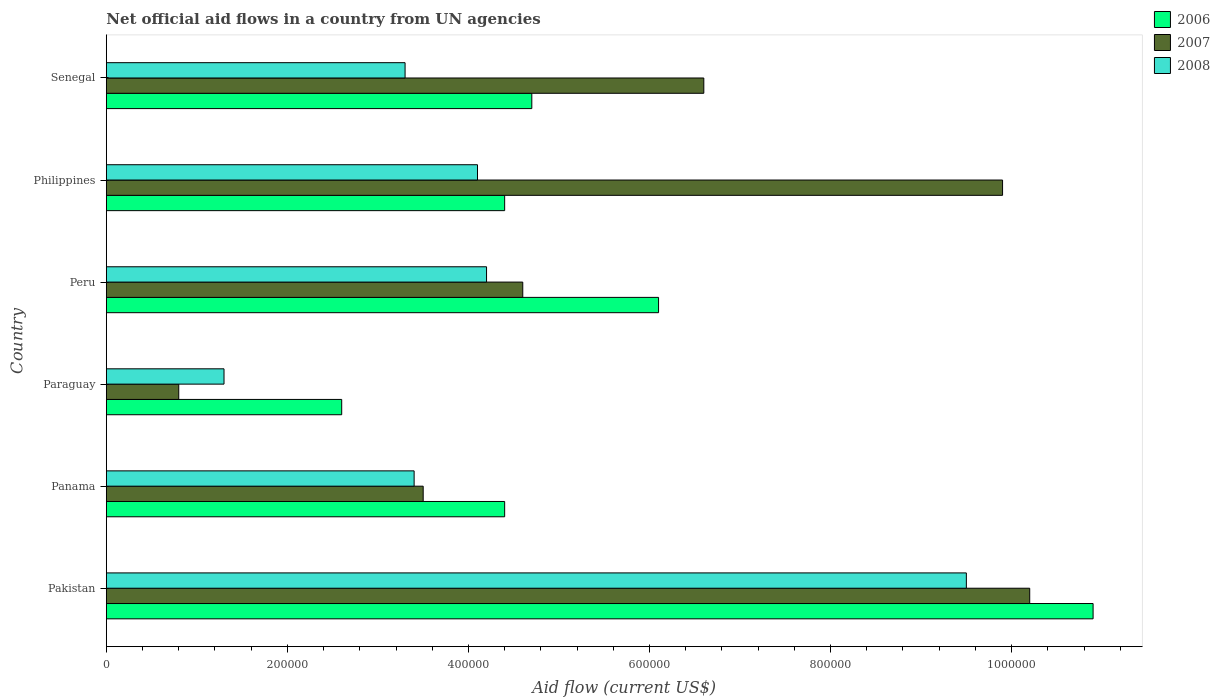How many different coloured bars are there?
Provide a short and direct response. 3. How many groups of bars are there?
Make the answer very short. 6. How many bars are there on the 3rd tick from the top?
Provide a short and direct response. 3. What is the net official aid flow in 2008 in Paraguay?
Ensure brevity in your answer.  1.30e+05. Across all countries, what is the maximum net official aid flow in 2008?
Offer a terse response. 9.50e+05. Across all countries, what is the minimum net official aid flow in 2006?
Make the answer very short. 2.60e+05. In which country was the net official aid flow in 2006 minimum?
Keep it short and to the point. Paraguay. What is the total net official aid flow in 2006 in the graph?
Keep it short and to the point. 3.31e+06. What is the average net official aid flow in 2006 per country?
Provide a short and direct response. 5.52e+05. What is the difference between the net official aid flow in 2006 and net official aid flow in 2008 in Paraguay?
Provide a short and direct response. 1.30e+05. What is the ratio of the net official aid flow in 2006 in Peru to that in Senegal?
Ensure brevity in your answer.  1.3. Is the net official aid flow in 2008 in Panama less than that in Paraguay?
Provide a short and direct response. No. What is the difference between the highest and the second highest net official aid flow in 2008?
Ensure brevity in your answer.  5.30e+05. What is the difference between the highest and the lowest net official aid flow in 2006?
Your response must be concise. 8.30e+05. In how many countries, is the net official aid flow in 2007 greater than the average net official aid flow in 2007 taken over all countries?
Keep it short and to the point. 3. What does the 1st bar from the top in Philippines represents?
Ensure brevity in your answer.  2008. What does the 1st bar from the bottom in Peru represents?
Give a very brief answer. 2006. Are all the bars in the graph horizontal?
Keep it short and to the point. Yes. How many countries are there in the graph?
Offer a very short reply. 6. What is the difference between two consecutive major ticks on the X-axis?
Provide a succinct answer. 2.00e+05. Does the graph contain any zero values?
Give a very brief answer. No. Does the graph contain grids?
Your answer should be very brief. No. How many legend labels are there?
Your answer should be compact. 3. What is the title of the graph?
Make the answer very short. Net official aid flows in a country from UN agencies. Does "1997" appear as one of the legend labels in the graph?
Provide a succinct answer. No. What is the label or title of the X-axis?
Your answer should be very brief. Aid flow (current US$). What is the Aid flow (current US$) of 2006 in Pakistan?
Offer a terse response. 1.09e+06. What is the Aid flow (current US$) in 2007 in Pakistan?
Provide a succinct answer. 1.02e+06. What is the Aid flow (current US$) of 2008 in Pakistan?
Your response must be concise. 9.50e+05. What is the Aid flow (current US$) in 2006 in Paraguay?
Provide a succinct answer. 2.60e+05. What is the Aid flow (current US$) in 2007 in Paraguay?
Your response must be concise. 8.00e+04. What is the Aid flow (current US$) in 2007 in Peru?
Ensure brevity in your answer.  4.60e+05. What is the Aid flow (current US$) of 2008 in Peru?
Provide a short and direct response. 4.20e+05. What is the Aid flow (current US$) of 2006 in Philippines?
Your response must be concise. 4.40e+05. What is the Aid flow (current US$) of 2007 in Philippines?
Offer a terse response. 9.90e+05. What is the Aid flow (current US$) of 2008 in Philippines?
Your response must be concise. 4.10e+05. What is the Aid flow (current US$) in 2007 in Senegal?
Give a very brief answer. 6.60e+05. Across all countries, what is the maximum Aid flow (current US$) in 2006?
Offer a terse response. 1.09e+06. Across all countries, what is the maximum Aid flow (current US$) of 2007?
Your response must be concise. 1.02e+06. Across all countries, what is the maximum Aid flow (current US$) of 2008?
Your answer should be compact. 9.50e+05. Across all countries, what is the minimum Aid flow (current US$) in 2006?
Your response must be concise. 2.60e+05. What is the total Aid flow (current US$) of 2006 in the graph?
Your response must be concise. 3.31e+06. What is the total Aid flow (current US$) in 2007 in the graph?
Make the answer very short. 3.56e+06. What is the total Aid flow (current US$) of 2008 in the graph?
Provide a succinct answer. 2.58e+06. What is the difference between the Aid flow (current US$) in 2006 in Pakistan and that in Panama?
Ensure brevity in your answer.  6.50e+05. What is the difference between the Aid flow (current US$) of 2007 in Pakistan and that in Panama?
Your answer should be compact. 6.70e+05. What is the difference between the Aid flow (current US$) of 2006 in Pakistan and that in Paraguay?
Offer a terse response. 8.30e+05. What is the difference between the Aid flow (current US$) in 2007 in Pakistan and that in Paraguay?
Your response must be concise. 9.40e+05. What is the difference between the Aid flow (current US$) of 2008 in Pakistan and that in Paraguay?
Keep it short and to the point. 8.20e+05. What is the difference between the Aid flow (current US$) of 2006 in Pakistan and that in Peru?
Your answer should be very brief. 4.80e+05. What is the difference between the Aid flow (current US$) in 2007 in Pakistan and that in Peru?
Keep it short and to the point. 5.60e+05. What is the difference between the Aid flow (current US$) in 2008 in Pakistan and that in Peru?
Provide a succinct answer. 5.30e+05. What is the difference between the Aid flow (current US$) of 2006 in Pakistan and that in Philippines?
Your answer should be very brief. 6.50e+05. What is the difference between the Aid flow (current US$) of 2007 in Pakistan and that in Philippines?
Keep it short and to the point. 3.00e+04. What is the difference between the Aid flow (current US$) in 2008 in Pakistan and that in Philippines?
Offer a terse response. 5.40e+05. What is the difference between the Aid flow (current US$) in 2006 in Pakistan and that in Senegal?
Your response must be concise. 6.20e+05. What is the difference between the Aid flow (current US$) of 2008 in Pakistan and that in Senegal?
Your answer should be compact. 6.20e+05. What is the difference between the Aid flow (current US$) in 2006 in Panama and that in Paraguay?
Keep it short and to the point. 1.80e+05. What is the difference between the Aid flow (current US$) of 2008 in Panama and that in Peru?
Offer a terse response. -8.00e+04. What is the difference between the Aid flow (current US$) in 2006 in Panama and that in Philippines?
Offer a very short reply. 0. What is the difference between the Aid flow (current US$) in 2007 in Panama and that in Philippines?
Your answer should be compact. -6.40e+05. What is the difference between the Aid flow (current US$) of 2006 in Panama and that in Senegal?
Ensure brevity in your answer.  -3.00e+04. What is the difference between the Aid flow (current US$) in 2007 in Panama and that in Senegal?
Give a very brief answer. -3.10e+05. What is the difference between the Aid flow (current US$) in 2008 in Panama and that in Senegal?
Make the answer very short. 10000. What is the difference between the Aid flow (current US$) in 2006 in Paraguay and that in Peru?
Make the answer very short. -3.50e+05. What is the difference between the Aid flow (current US$) of 2007 in Paraguay and that in Peru?
Make the answer very short. -3.80e+05. What is the difference between the Aid flow (current US$) of 2008 in Paraguay and that in Peru?
Offer a terse response. -2.90e+05. What is the difference between the Aid flow (current US$) of 2006 in Paraguay and that in Philippines?
Your response must be concise. -1.80e+05. What is the difference between the Aid flow (current US$) in 2007 in Paraguay and that in Philippines?
Your answer should be very brief. -9.10e+05. What is the difference between the Aid flow (current US$) in 2008 in Paraguay and that in Philippines?
Provide a succinct answer. -2.80e+05. What is the difference between the Aid flow (current US$) of 2006 in Paraguay and that in Senegal?
Provide a succinct answer. -2.10e+05. What is the difference between the Aid flow (current US$) of 2007 in Paraguay and that in Senegal?
Keep it short and to the point. -5.80e+05. What is the difference between the Aid flow (current US$) of 2006 in Peru and that in Philippines?
Offer a very short reply. 1.70e+05. What is the difference between the Aid flow (current US$) of 2007 in Peru and that in Philippines?
Your answer should be very brief. -5.30e+05. What is the difference between the Aid flow (current US$) in 2008 in Peru and that in Philippines?
Your answer should be compact. 10000. What is the difference between the Aid flow (current US$) in 2006 in Philippines and that in Senegal?
Your answer should be compact. -3.00e+04. What is the difference between the Aid flow (current US$) in 2008 in Philippines and that in Senegal?
Your answer should be very brief. 8.00e+04. What is the difference between the Aid flow (current US$) of 2006 in Pakistan and the Aid flow (current US$) of 2007 in Panama?
Give a very brief answer. 7.40e+05. What is the difference between the Aid flow (current US$) in 2006 in Pakistan and the Aid flow (current US$) in 2008 in Panama?
Offer a terse response. 7.50e+05. What is the difference between the Aid flow (current US$) in 2007 in Pakistan and the Aid flow (current US$) in 2008 in Panama?
Give a very brief answer. 6.80e+05. What is the difference between the Aid flow (current US$) of 2006 in Pakistan and the Aid flow (current US$) of 2007 in Paraguay?
Provide a short and direct response. 1.01e+06. What is the difference between the Aid flow (current US$) of 2006 in Pakistan and the Aid flow (current US$) of 2008 in Paraguay?
Your response must be concise. 9.60e+05. What is the difference between the Aid flow (current US$) in 2007 in Pakistan and the Aid flow (current US$) in 2008 in Paraguay?
Offer a very short reply. 8.90e+05. What is the difference between the Aid flow (current US$) of 2006 in Pakistan and the Aid flow (current US$) of 2007 in Peru?
Your answer should be compact. 6.30e+05. What is the difference between the Aid flow (current US$) of 2006 in Pakistan and the Aid flow (current US$) of 2008 in Peru?
Offer a terse response. 6.70e+05. What is the difference between the Aid flow (current US$) of 2007 in Pakistan and the Aid flow (current US$) of 2008 in Peru?
Your answer should be very brief. 6.00e+05. What is the difference between the Aid flow (current US$) in 2006 in Pakistan and the Aid flow (current US$) in 2007 in Philippines?
Offer a terse response. 1.00e+05. What is the difference between the Aid flow (current US$) of 2006 in Pakistan and the Aid flow (current US$) of 2008 in Philippines?
Your answer should be compact. 6.80e+05. What is the difference between the Aid flow (current US$) of 2006 in Pakistan and the Aid flow (current US$) of 2008 in Senegal?
Make the answer very short. 7.60e+05. What is the difference between the Aid flow (current US$) of 2007 in Pakistan and the Aid flow (current US$) of 2008 in Senegal?
Offer a terse response. 6.90e+05. What is the difference between the Aid flow (current US$) of 2006 in Panama and the Aid flow (current US$) of 2007 in Paraguay?
Your answer should be very brief. 3.60e+05. What is the difference between the Aid flow (current US$) in 2006 in Panama and the Aid flow (current US$) in 2008 in Paraguay?
Your response must be concise. 3.10e+05. What is the difference between the Aid flow (current US$) of 2007 in Panama and the Aid flow (current US$) of 2008 in Peru?
Keep it short and to the point. -7.00e+04. What is the difference between the Aid flow (current US$) in 2006 in Panama and the Aid flow (current US$) in 2007 in Philippines?
Ensure brevity in your answer.  -5.50e+05. What is the difference between the Aid flow (current US$) of 2006 in Panama and the Aid flow (current US$) of 2008 in Philippines?
Your answer should be very brief. 3.00e+04. What is the difference between the Aid flow (current US$) in 2006 in Panama and the Aid flow (current US$) in 2008 in Senegal?
Make the answer very short. 1.10e+05. What is the difference between the Aid flow (current US$) in 2007 in Panama and the Aid flow (current US$) in 2008 in Senegal?
Keep it short and to the point. 2.00e+04. What is the difference between the Aid flow (current US$) of 2007 in Paraguay and the Aid flow (current US$) of 2008 in Peru?
Ensure brevity in your answer.  -3.40e+05. What is the difference between the Aid flow (current US$) of 2006 in Paraguay and the Aid flow (current US$) of 2007 in Philippines?
Provide a succinct answer. -7.30e+05. What is the difference between the Aid flow (current US$) of 2007 in Paraguay and the Aid flow (current US$) of 2008 in Philippines?
Provide a short and direct response. -3.30e+05. What is the difference between the Aid flow (current US$) of 2006 in Paraguay and the Aid flow (current US$) of 2007 in Senegal?
Offer a terse response. -4.00e+05. What is the difference between the Aid flow (current US$) of 2006 in Paraguay and the Aid flow (current US$) of 2008 in Senegal?
Your answer should be compact. -7.00e+04. What is the difference between the Aid flow (current US$) of 2006 in Peru and the Aid flow (current US$) of 2007 in Philippines?
Provide a succinct answer. -3.80e+05. What is the difference between the Aid flow (current US$) of 2006 in Peru and the Aid flow (current US$) of 2007 in Senegal?
Give a very brief answer. -5.00e+04. What is the difference between the Aid flow (current US$) in 2006 in Philippines and the Aid flow (current US$) in 2007 in Senegal?
Your answer should be compact. -2.20e+05. What is the difference between the Aid flow (current US$) of 2006 in Philippines and the Aid flow (current US$) of 2008 in Senegal?
Your answer should be compact. 1.10e+05. What is the difference between the Aid flow (current US$) of 2007 in Philippines and the Aid flow (current US$) of 2008 in Senegal?
Provide a short and direct response. 6.60e+05. What is the average Aid flow (current US$) of 2006 per country?
Provide a succinct answer. 5.52e+05. What is the average Aid flow (current US$) in 2007 per country?
Offer a terse response. 5.93e+05. What is the average Aid flow (current US$) of 2008 per country?
Give a very brief answer. 4.30e+05. What is the difference between the Aid flow (current US$) of 2006 and Aid flow (current US$) of 2008 in Panama?
Make the answer very short. 1.00e+05. What is the difference between the Aid flow (current US$) in 2007 and Aid flow (current US$) in 2008 in Panama?
Give a very brief answer. 10000. What is the difference between the Aid flow (current US$) of 2006 and Aid flow (current US$) of 2007 in Paraguay?
Offer a very short reply. 1.80e+05. What is the difference between the Aid flow (current US$) of 2006 and Aid flow (current US$) of 2007 in Peru?
Provide a short and direct response. 1.50e+05. What is the difference between the Aid flow (current US$) in 2006 and Aid flow (current US$) in 2007 in Philippines?
Provide a short and direct response. -5.50e+05. What is the difference between the Aid flow (current US$) in 2006 and Aid flow (current US$) in 2008 in Philippines?
Keep it short and to the point. 3.00e+04. What is the difference between the Aid flow (current US$) in 2007 and Aid flow (current US$) in 2008 in Philippines?
Your answer should be compact. 5.80e+05. What is the ratio of the Aid flow (current US$) in 2006 in Pakistan to that in Panama?
Ensure brevity in your answer.  2.48. What is the ratio of the Aid flow (current US$) of 2007 in Pakistan to that in Panama?
Offer a very short reply. 2.91. What is the ratio of the Aid flow (current US$) of 2008 in Pakistan to that in Panama?
Offer a terse response. 2.79. What is the ratio of the Aid flow (current US$) in 2006 in Pakistan to that in Paraguay?
Provide a succinct answer. 4.19. What is the ratio of the Aid flow (current US$) in 2007 in Pakistan to that in Paraguay?
Your response must be concise. 12.75. What is the ratio of the Aid flow (current US$) of 2008 in Pakistan to that in Paraguay?
Provide a succinct answer. 7.31. What is the ratio of the Aid flow (current US$) of 2006 in Pakistan to that in Peru?
Provide a short and direct response. 1.79. What is the ratio of the Aid flow (current US$) of 2007 in Pakistan to that in Peru?
Your answer should be compact. 2.22. What is the ratio of the Aid flow (current US$) of 2008 in Pakistan to that in Peru?
Provide a short and direct response. 2.26. What is the ratio of the Aid flow (current US$) of 2006 in Pakistan to that in Philippines?
Your answer should be very brief. 2.48. What is the ratio of the Aid flow (current US$) in 2007 in Pakistan to that in Philippines?
Provide a succinct answer. 1.03. What is the ratio of the Aid flow (current US$) in 2008 in Pakistan to that in Philippines?
Your answer should be very brief. 2.32. What is the ratio of the Aid flow (current US$) in 2006 in Pakistan to that in Senegal?
Ensure brevity in your answer.  2.32. What is the ratio of the Aid flow (current US$) of 2007 in Pakistan to that in Senegal?
Offer a terse response. 1.55. What is the ratio of the Aid flow (current US$) in 2008 in Pakistan to that in Senegal?
Ensure brevity in your answer.  2.88. What is the ratio of the Aid flow (current US$) in 2006 in Panama to that in Paraguay?
Provide a succinct answer. 1.69. What is the ratio of the Aid flow (current US$) in 2007 in Panama to that in Paraguay?
Give a very brief answer. 4.38. What is the ratio of the Aid flow (current US$) in 2008 in Panama to that in Paraguay?
Give a very brief answer. 2.62. What is the ratio of the Aid flow (current US$) of 2006 in Panama to that in Peru?
Provide a succinct answer. 0.72. What is the ratio of the Aid flow (current US$) in 2007 in Panama to that in Peru?
Give a very brief answer. 0.76. What is the ratio of the Aid flow (current US$) of 2008 in Panama to that in Peru?
Your answer should be compact. 0.81. What is the ratio of the Aid flow (current US$) of 2006 in Panama to that in Philippines?
Provide a succinct answer. 1. What is the ratio of the Aid flow (current US$) in 2007 in Panama to that in Philippines?
Offer a terse response. 0.35. What is the ratio of the Aid flow (current US$) of 2008 in Panama to that in Philippines?
Ensure brevity in your answer.  0.83. What is the ratio of the Aid flow (current US$) of 2006 in Panama to that in Senegal?
Provide a succinct answer. 0.94. What is the ratio of the Aid flow (current US$) in 2007 in Panama to that in Senegal?
Offer a very short reply. 0.53. What is the ratio of the Aid flow (current US$) in 2008 in Panama to that in Senegal?
Provide a succinct answer. 1.03. What is the ratio of the Aid flow (current US$) in 2006 in Paraguay to that in Peru?
Ensure brevity in your answer.  0.43. What is the ratio of the Aid flow (current US$) of 2007 in Paraguay to that in Peru?
Provide a succinct answer. 0.17. What is the ratio of the Aid flow (current US$) in 2008 in Paraguay to that in Peru?
Keep it short and to the point. 0.31. What is the ratio of the Aid flow (current US$) of 2006 in Paraguay to that in Philippines?
Ensure brevity in your answer.  0.59. What is the ratio of the Aid flow (current US$) of 2007 in Paraguay to that in Philippines?
Give a very brief answer. 0.08. What is the ratio of the Aid flow (current US$) in 2008 in Paraguay to that in Philippines?
Your response must be concise. 0.32. What is the ratio of the Aid flow (current US$) in 2006 in Paraguay to that in Senegal?
Provide a short and direct response. 0.55. What is the ratio of the Aid flow (current US$) in 2007 in Paraguay to that in Senegal?
Offer a very short reply. 0.12. What is the ratio of the Aid flow (current US$) of 2008 in Paraguay to that in Senegal?
Offer a very short reply. 0.39. What is the ratio of the Aid flow (current US$) of 2006 in Peru to that in Philippines?
Make the answer very short. 1.39. What is the ratio of the Aid flow (current US$) in 2007 in Peru to that in Philippines?
Provide a succinct answer. 0.46. What is the ratio of the Aid flow (current US$) in 2008 in Peru to that in Philippines?
Offer a terse response. 1.02. What is the ratio of the Aid flow (current US$) of 2006 in Peru to that in Senegal?
Your response must be concise. 1.3. What is the ratio of the Aid flow (current US$) in 2007 in Peru to that in Senegal?
Provide a short and direct response. 0.7. What is the ratio of the Aid flow (current US$) of 2008 in Peru to that in Senegal?
Ensure brevity in your answer.  1.27. What is the ratio of the Aid flow (current US$) of 2006 in Philippines to that in Senegal?
Provide a short and direct response. 0.94. What is the ratio of the Aid flow (current US$) in 2007 in Philippines to that in Senegal?
Ensure brevity in your answer.  1.5. What is the ratio of the Aid flow (current US$) of 2008 in Philippines to that in Senegal?
Give a very brief answer. 1.24. What is the difference between the highest and the second highest Aid flow (current US$) in 2007?
Make the answer very short. 3.00e+04. What is the difference between the highest and the second highest Aid flow (current US$) of 2008?
Keep it short and to the point. 5.30e+05. What is the difference between the highest and the lowest Aid flow (current US$) of 2006?
Your response must be concise. 8.30e+05. What is the difference between the highest and the lowest Aid flow (current US$) in 2007?
Keep it short and to the point. 9.40e+05. What is the difference between the highest and the lowest Aid flow (current US$) in 2008?
Your answer should be compact. 8.20e+05. 